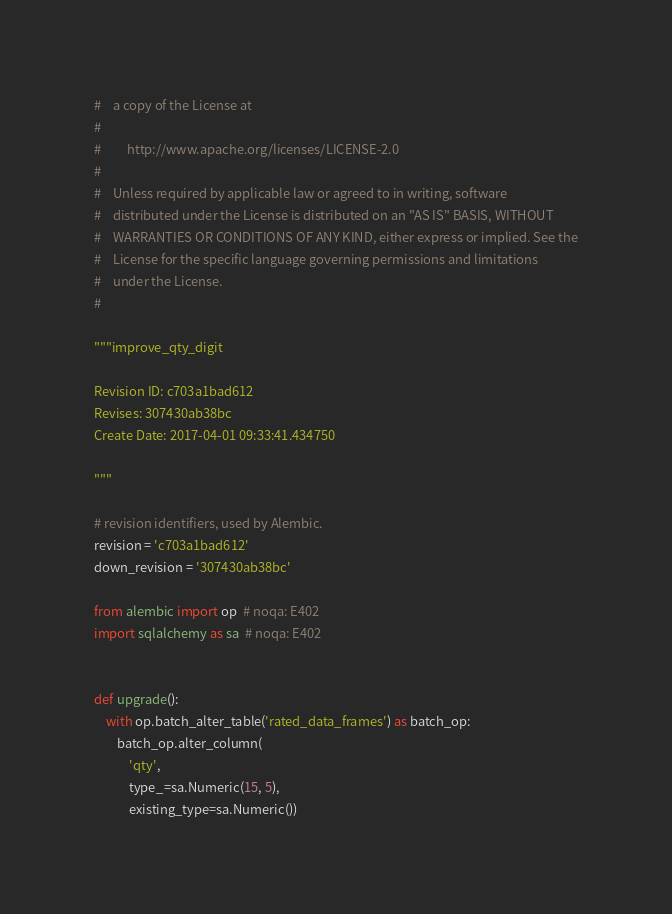<code> <loc_0><loc_0><loc_500><loc_500><_Python_>#    a copy of the License at
#
#         http://www.apache.org/licenses/LICENSE-2.0
#
#    Unless required by applicable law or agreed to in writing, software
#    distributed under the License is distributed on an "AS IS" BASIS, WITHOUT
#    WARRANTIES OR CONDITIONS OF ANY KIND, either express or implied. See the
#    License for the specific language governing permissions and limitations
#    under the License.
#

"""improve_qty_digit

Revision ID: c703a1bad612
Revises: 307430ab38bc
Create Date: 2017-04-01 09:33:41.434750

"""

# revision identifiers, used by Alembic.
revision = 'c703a1bad612'
down_revision = '307430ab38bc'

from alembic import op  # noqa: E402
import sqlalchemy as sa  # noqa: E402


def upgrade():
    with op.batch_alter_table('rated_data_frames') as batch_op:
        batch_op.alter_column(
            'qty',
            type_=sa.Numeric(15, 5),
            existing_type=sa.Numeric())
</code> 